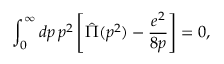<formula> <loc_0><loc_0><loc_500><loc_500>\int _ { 0 } ^ { \infty } d p \, p ^ { 2 } \left [ \hat { \Pi } ( p ^ { 2 } ) - \frac { e ^ { 2 } } { 8 p } \right ] = 0 ,</formula> 